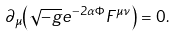<formula> <loc_0><loc_0><loc_500><loc_500>\partial _ { \mu } { \left ( \sqrt { - g } e ^ { - 2 \alpha \Phi } F ^ { \mu \nu } \right ) } = 0 .</formula> 